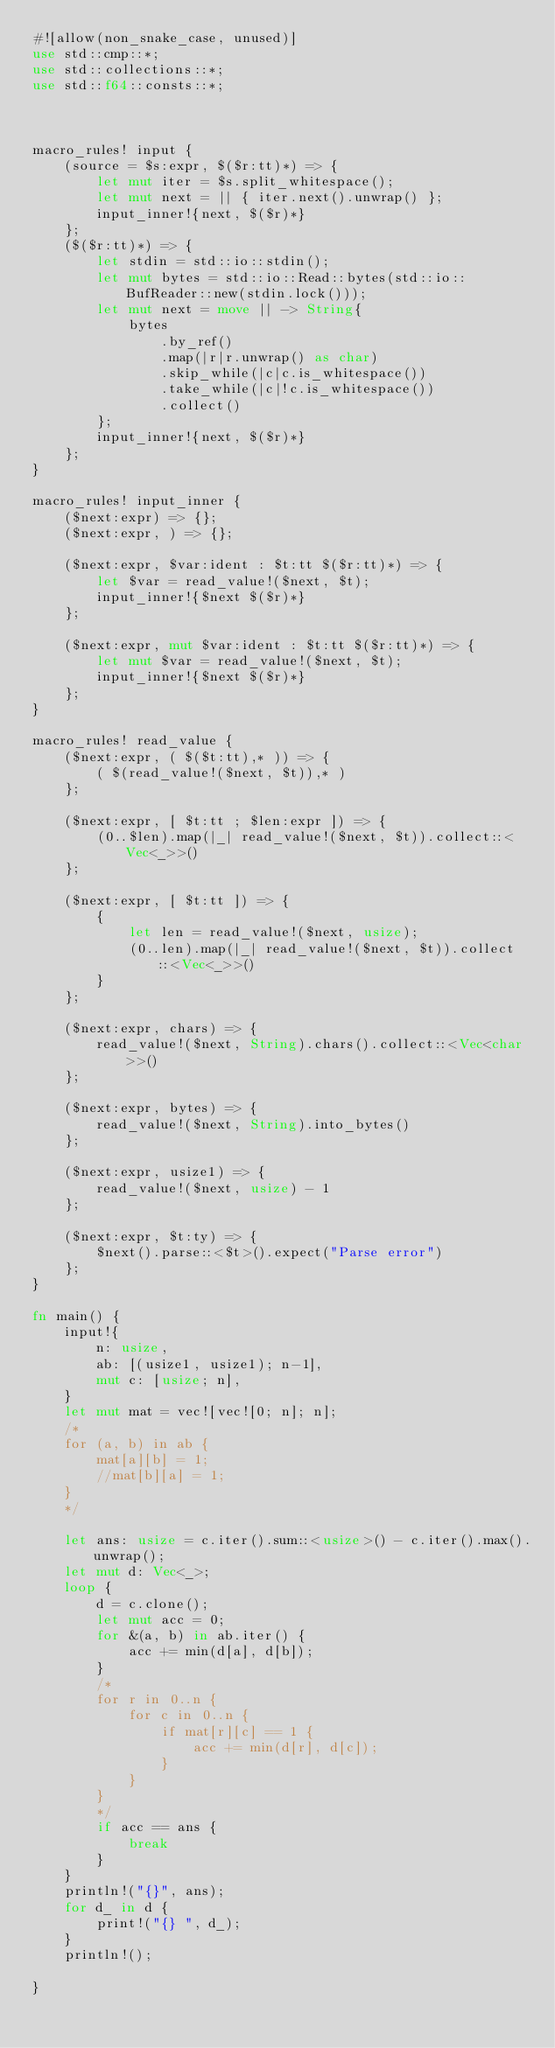<code> <loc_0><loc_0><loc_500><loc_500><_Rust_>#![allow(non_snake_case, unused)]
use std::cmp::*;
use std::collections::*;
use std::f64::consts::*;



macro_rules! input {
    (source = $s:expr, $($r:tt)*) => {
        let mut iter = $s.split_whitespace();
        let mut next = || { iter.next().unwrap() };
        input_inner!{next, $($r)*}
    };
    ($($r:tt)*) => {
        let stdin = std::io::stdin();
        let mut bytes = std::io::Read::bytes(std::io::BufReader::new(stdin.lock()));
        let mut next = move || -> String{
            bytes
                .by_ref()
                .map(|r|r.unwrap() as char)
                .skip_while(|c|c.is_whitespace())
                .take_while(|c|!c.is_whitespace())
                .collect()
        };
        input_inner!{next, $($r)*}
    };
}

macro_rules! input_inner {
    ($next:expr) => {};
    ($next:expr, ) => {};

    ($next:expr, $var:ident : $t:tt $($r:tt)*) => {
        let $var = read_value!($next, $t);
        input_inner!{$next $($r)*}
    };

    ($next:expr, mut $var:ident : $t:tt $($r:tt)*) => {
        let mut $var = read_value!($next, $t);
        input_inner!{$next $($r)*}
    };
}

macro_rules! read_value {
    ($next:expr, ( $($t:tt),* )) => {
        ( $(read_value!($next, $t)),* )
    };

    ($next:expr, [ $t:tt ; $len:expr ]) => {
        (0..$len).map(|_| read_value!($next, $t)).collect::<Vec<_>>()
    };

    ($next:expr, [ $t:tt ]) => {
        {
            let len = read_value!($next, usize);
            (0..len).map(|_| read_value!($next, $t)).collect::<Vec<_>>()
        }
    };

    ($next:expr, chars) => {
        read_value!($next, String).chars().collect::<Vec<char>>()
    };

    ($next:expr, bytes) => {
        read_value!($next, String).into_bytes()
    };

    ($next:expr, usize1) => {
        read_value!($next, usize) - 1
    };

    ($next:expr, $t:ty) => {
        $next().parse::<$t>().expect("Parse error")
    };
}

fn main() {
    input!{
        n: usize,
        ab: [(usize1, usize1); n-1],
        mut c: [usize; n],
    }
    let mut mat = vec![vec![0; n]; n];
    /*
    for (a, b) in ab {
        mat[a][b] = 1;
        //mat[b][a] = 1;
    }
    */

    let ans: usize = c.iter().sum::<usize>() - c.iter().max().unwrap();
    let mut d: Vec<_>;
    loop {
        d = c.clone();
        let mut acc = 0;
        for &(a, b) in ab.iter() {
            acc += min(d[a], d[b]);
        }
        /*
        for r in 0..n {
            for c in 0..n {
                if mat[r][c] == 1 {
                    acc += min(d[r], d[c]);
                }
            }
        }
        */
        if acc == ans {
            break
        }
    }
    println!("{}", ans);
    for d_ in d {
        print!("{} ", d_);
    }
    println!();

}
</code> 